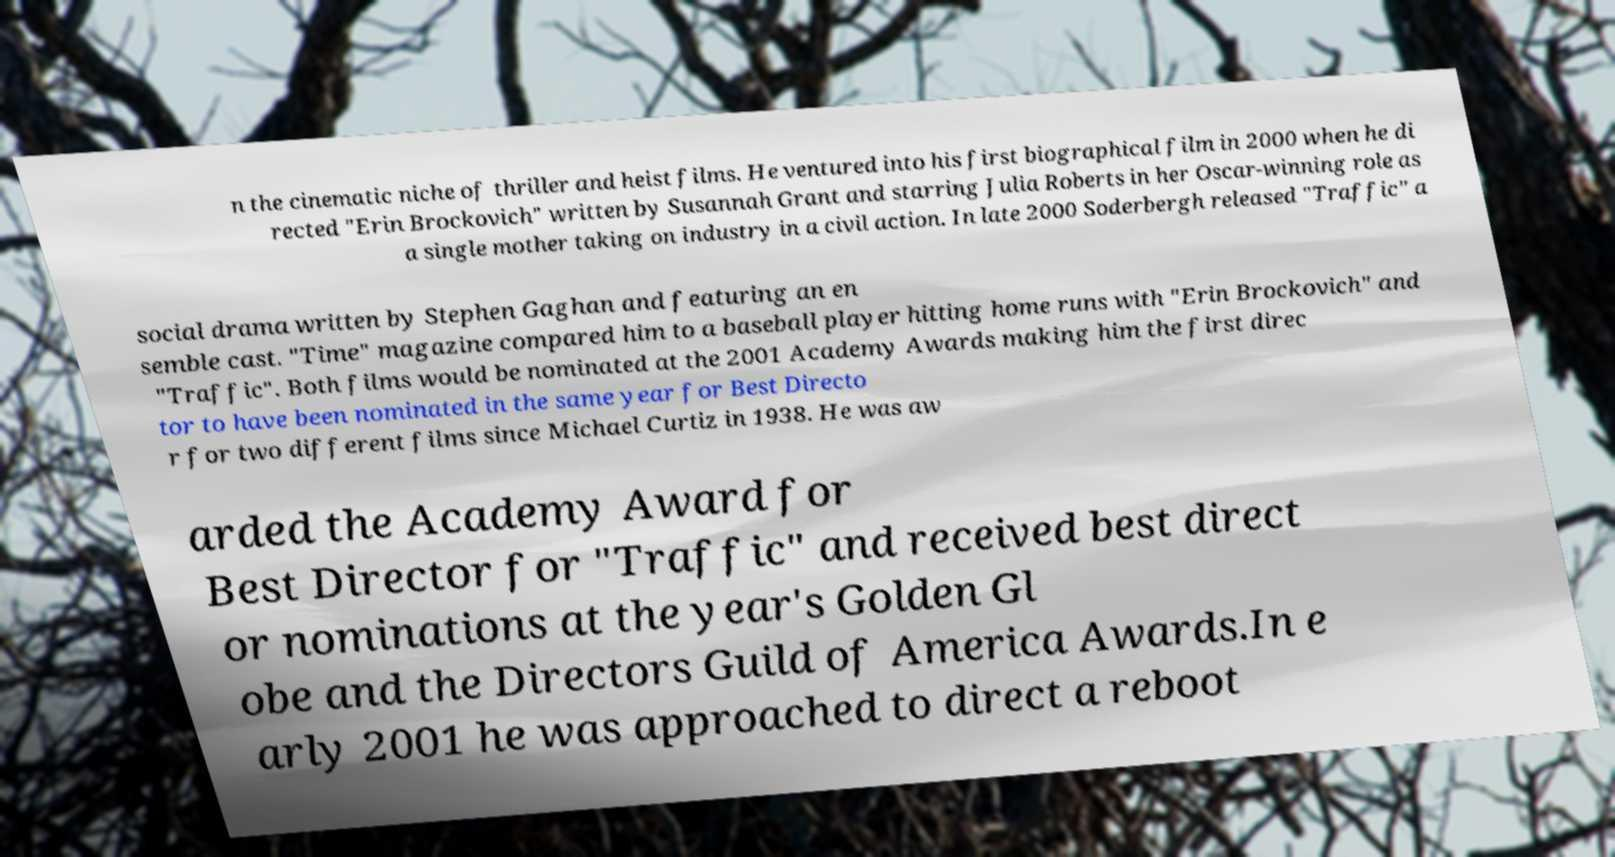For documentation purposes, I need the text within this image transcribed. Could you provide that? n the cinematic niche of thriller and heist films. He ventured into his first biographical film in 2000 when he di rected "Erin Brockovich" written by Susannah Grant and starring Julia Roberts in her Oscar-winning role as a single mother taking on industry in a civil action. In late 2000 Soderbergh released "Traffic" a social drama written by Stephen Gaghan and featuring an en semble cast. "Time" magazine compared him to a baseball player hitting home runs with "Erin Brockovich" and "Traffic". Both films would be nominated at the 2001 Academy Awards making him the first direc tor to have been nominated in the same year for Best Directo r for two different films since Michael Curtiz in 1938. He was aw arded the Academy Award for Best Director for "Traffic" and received best direct or nominations at the year's Golden Gl obe and the Directors Guild of America Awards.In e arly 2001 he was approached to direct a reboot 